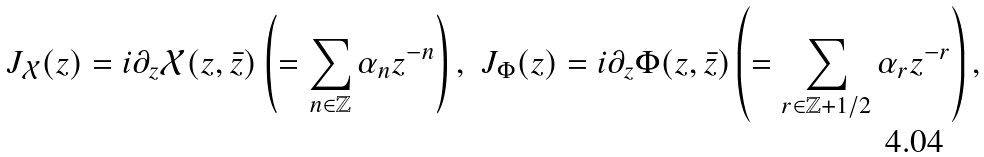<formula> <loc_0><loc_0><loc_500><loc_500>J _ { \mathcal { X } } ( z ) = i \partial _ { z } \mathcal { X } ( z , \bar { z } ) \left ( = \sum _ { n \in \mathbb { Z } } \alpha _ { n } z ^ { - n } \right ) \text {, \ } J _ { \Phi } ( z ) = i \partial _ { z } \Phi ( z , \bar { z } ) \left ( = \sum _ { r \in \mathbb { Z } + 1 / 2 } \alpha _ { r } z ^ { - r } \right ) ,</formula> 